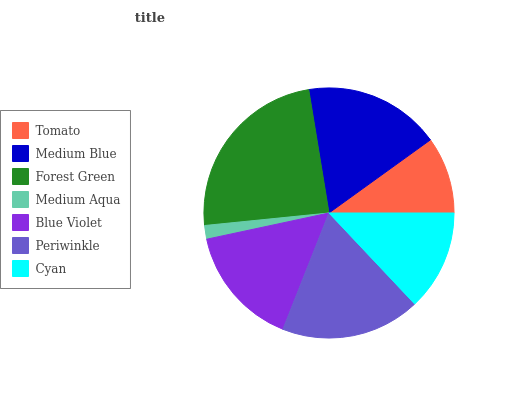Is Medium Aqua the minimum?
Answer yes or no. Yes. Is Forest Green the maximum?
Answer yes or no. Yes. Is Medium Blue the minimum?
Answer yes or no. No. Is Medium Blue the maximum?
Answer yes or no. No. Is Medium Blue greater than Tomato?
Answer yes or no. Yes. Is Tomato less than Medium Blue?
Answer yes or no. Yes. Is Tomato greater than Medium Blue?
Answer yes or no. No. Is Medium Blue less than Tomato?
Answer yes or no. No. Is Blue Violet the high median?
Answer yes or no. Yes. Is Blue Violet the low median?
Answer yes or no. Yes. Is Tomato the high median?
Answer yes or no. No. Is Medium Aqua the low median?
Answer yes or no. No. 